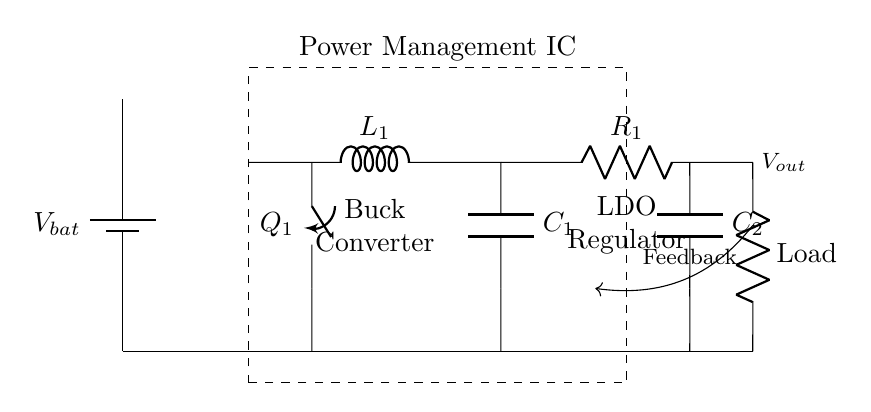What is the main component that manages power in this circuit? The main component is the Power Management IC, which is indicated by a dashed rectangle enclosing several components. Its primary role is to regulate and distribute power efficiently.
Answer: Power Management IC What type of converter is used in this circuit? A buck converter is used, which is explicitly labeled in the circuit. Buck converters step down voltage while increasing current, making them suitable for battery-powered devices.
Answer: Buck Converter What is the role of component labeled C1 in the circuit? C1 is a capacitor connected at the output of the buck converter, indicating its function in smoothing out voltage fluctuations at the output to provide stable power to the load.
Answer: Smoothing What does the feedback connection do in this power management circuit? The feedback connection, indicated by an arrow, helps regulate the output voltage by feeding back a portion of it to the Power Management IC, allowing it to adjust the operation of the converter for stable output.
Answer: Regulation How many total loads are connected in the circuit? The circuit shows one load connected, specifically labeled as "Load." This indicates that there is a single load being powered in the given configuration.
Answer: One What is the value of the inductor labeled L1 in this circuit? The value is not explicitly given in the diagram, but typically inductor values are critical in buck converter designs to control current flow and energy storage during the switching cycle. In this case, a specific value would depend on the design specifications.
Answer: Not specified 